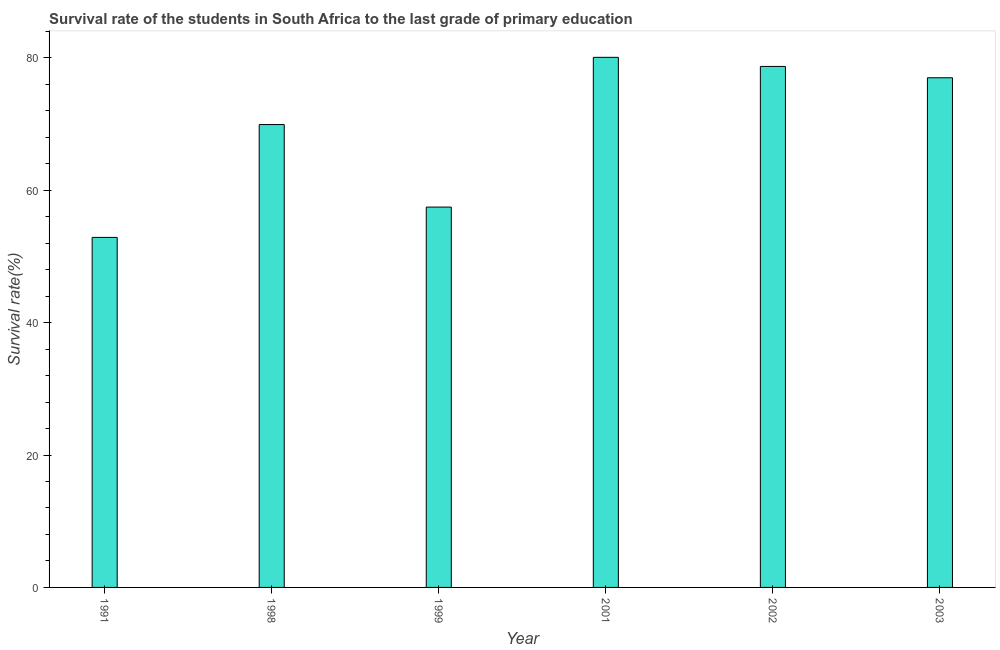Does the graph contain any zero values?
Make the answer very short. No. What is the title of the graph?
Make the answer very short. Survival rate of the students in South Africa to the last grade of primary education. What is the label or title of the X-axis?
Offer a very short reply. Year. What is the label or title of the Y-axis?
Offer a terse response. Survival rate(%). What is the survival rate in primary education in 2003?
Offer a terse response. 76.99. Across all years, what is the maximum survival rate in primary education?
Your response must be concise. 80.07. Across all years, what is the minimum survival rate in primary education?
Your answer should be very brief. 52.87. In which year was the survival rate in primary education maximum?
Ensure brevity in your answer.  2001. In which year was the survival rate in primary education minimum?
Offer a very short reply. 1991. What is the sum of the survival rate in primary education?
Make the answer very short. 416. What is the difference between the survival rate in primary education in 1999 and 2002?
Your answer should be compact. -21.25. What is the average survival rate in primary education per year?
Your answer should be compact. 69.33. What is the median survival rate in primary education?
Offer a very short reply. 73.45. In how many years, is the survival rate in primary education greater than 44 %?
Your response must be concise. 6. Do a majority of the years between 1991 and 2002 (inclusive) have survival rate in primary education greater than 12 %?
Your answer should be very brief. Yes. What is the ratio of the survival rate in primary education in 1991 to that in 1998?
Ensure brevity in your answer.  0.76. Is the difference between the survival rate in primary education in 1991 and 2002 greater than the difference between any two years?
Provide a succinct answer. No. What is the difference between the highest and the second highest survival rate in primary education?
Make the answer very short. 1.37. Is the sum of the survival rate in primary education in 1999 and 2003 greater than the maximum survival rate in primary education across all years?
Give a very brief answer. Yes. What is the difference between the highest and the lowest survival rate in primary education?
Provide a succinct answer. 27.2. In how many years, is the survival rate in primary education greater than the average survival rate in primary education taken over all years?
Your response must be concise. 4. How many bars are there?
Your response must be concise. 6. Are all the bars in the graph horizontal?
Provide a succinct answer. No. How many years are there in the graph?
Offer a terse response. 6. What is the difference between two consecutive major ticks on the Y-axis?
Ensure brevity in your answer.  20. Are the values on the major ticks of Y-axis written in scientific E-notation?
Provide a succinct answer. No. What is the Survival rate(%) of 1991?
Ensure brevity in your answer.  52.87. What is the Survival rate(%) of 1998?
Offer a terse response. 69.92. What is the Survival rate(%) in 1999?
Keep it short and to the point. 57.45. What is the Survival rate(%) of 2001?
Give a very brief answer. 80.07. What is the Survival rate(%) in 2002?
Your answer should be compact. 78.7. What is the Survival rate(%) of 2003?
Your answer should be very brief. 76.99. What is the difference between the Survival rate(%) in 1991 and 1998?
Give a very brief answer. -17.05. What is the difference between the Survival rate(%) in 1991 and 1999?
Make the answer very short. -4.58. What is the difference between the Survival rate(%) in 1991 and 2001?
Your answer should be compact. -27.2. What is the difference between the Survival rate(%) in 1991 and 2002?
Provide a short and direct response. -25.83. What is the difference between the Survival rate(%) in 1991 and 2003?
Your answer should be compact. -24.11. What is the difference between the Survival rate(%) in 1998 and 1999?
Your response must be concise. 12.47. What is the difference between the Survival rate(%) in 1998 and 2001?
Your answer should be very brief. -10.15. What is the difference between the Survival rate(%) in 1998 and 2002?
Give a very brief answer. -8.78. What is the difference between the Survival rate(%) in 1998 and 2003?
Your response must be concise. -7.07. What is the difference between the Survival rate(%) in 1999 and 2001?
Make the answer very short. -22.62. What is the difference between the Survival rate(%) in 1999 and 2002?
Make the answer very short. -21.25. What is the difference between the Survival rate(%) in 1999 and 2003?
Provide a short and direct response. -19.53. What is the difference between the Survival rate(%) in 2001 and 2002?
Offer a terse response. 1.37. What is the difference between the Survival rate(%) in 2001 and 2003?
Provide a short and direct response. 3.09. What is the difference between the Survival rate(%) in 2002 and 2003?
Give a very brief answer. 1.71. What is the ratio of the Survival rate(%) in 1991 to that in 1998?
Ensure brevity in your answer.  0.76. What is the ratio of the Survival rate(%) in 1991 to that in 1999?
Keep it short and to the point. 0.92. What is the ratio of the Survival rate(%) in 1991 to that in 2001?
Your answer should be very brief. 0.66. What is the ratio of the Survival rate(%) in 1991 to that in 2002?
Give a very brief answer. 0.67. What is the ratio of the Survival rate(%) in 1991 to that in 2003?
Give a very brief answer. 0.69. What is the ratio of the Survival rate(%) in 1998 to that in 1999?
Your answer should be very brief. 1.22. What is the ratio of the Survival rate(%) in 1998 to that in 2001?
Offer a very short reply. 0.87. What is the ratio of the Survival rate(%) in 1998 to that in 2002?
Your answer should be very brief. 0.89. What is the ratio of the Survival rate(%) in 1998 to that in 2003?
Give a very brief answer. 0.91. What is the ratio of the Survival rate(%) in 1999 to that in 2001?
Keep it short and to the point. 0.72. What is the ratio of the Survival rate(%) in 1999 to that in 2002?
Ensure brevity in your answer.  0.73. What is the ratio of the Survival rate(%) in 1999 to that in 2003?
Your answer should be very brief. 0.75. What is the ratio of the Survival rate(%) in 2001 to that in 2002?
Ensure brevity in your answer.  1.02. What is the ratio of the Survival rate(%) in 2001 to that in 2003?
Give a very brief answer. 1.04. 